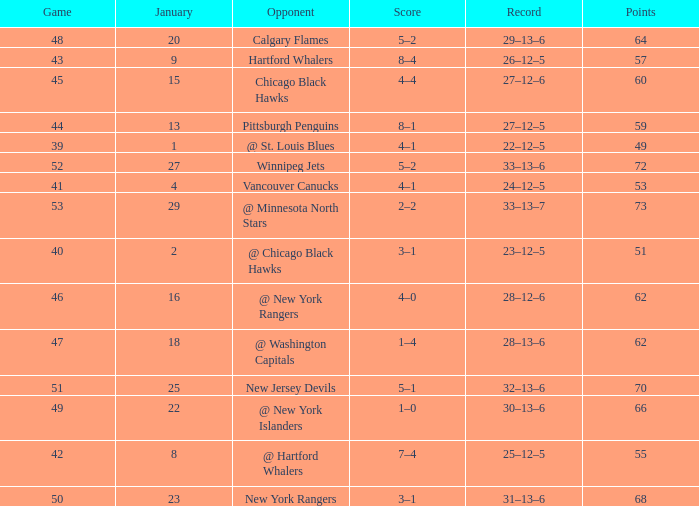Which Points have a Score of 4–1, and a Game smaller than 39? None. 